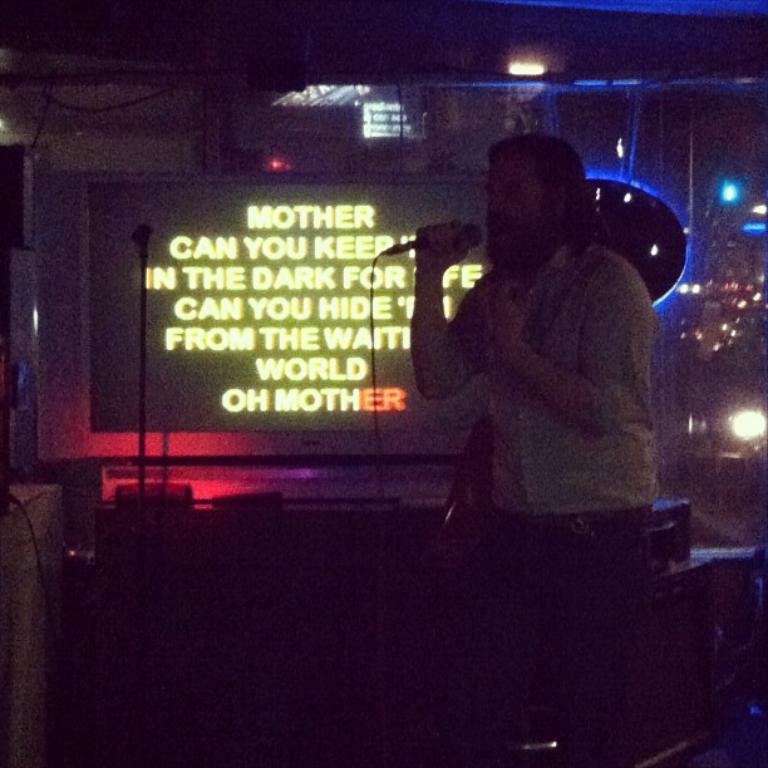Can you describe this image briefly? In the image there is a bearded man singing in the mic on a stage, behind him there is a screen, on the right side there are few lights. 